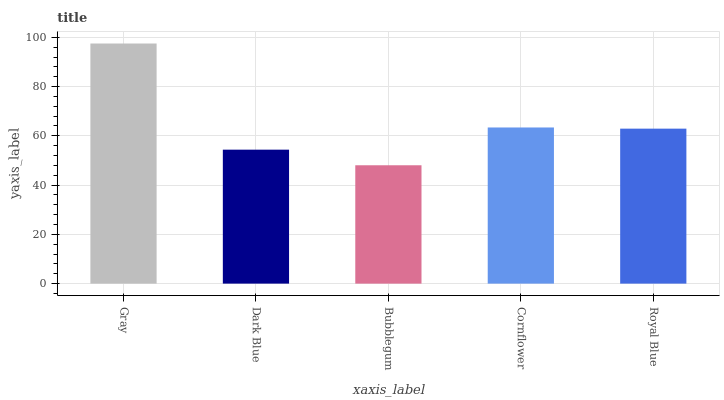Is Bubblegum the minimum?
Answer yes or no. Yes. Is Gray the maximum?
Answer yes or no. Yes. Is Dark Blue the minimum?
Answer yes or no. No. Is Dark Blue the maximum?
Answer yes or no. No. Is Gray greater than Dark Blue?
Answer yes or no. Yes. Is Dark Blue less than Gray?
Answer yes or no. Yes. Is Dark Blue greater than Gray?
Answer yes or no. No. Is Gray less than Dark Blue?
Answer yes or no. No. Is Royal Blue the high median?
Answer yes or no. Yes. Is Royal Blue the low median?
Answer yes or no. Yes. Is Bubblegum the high median?
Answer yes or no. No. Is Dark Blue the low median?
Answer yes or no. No. 